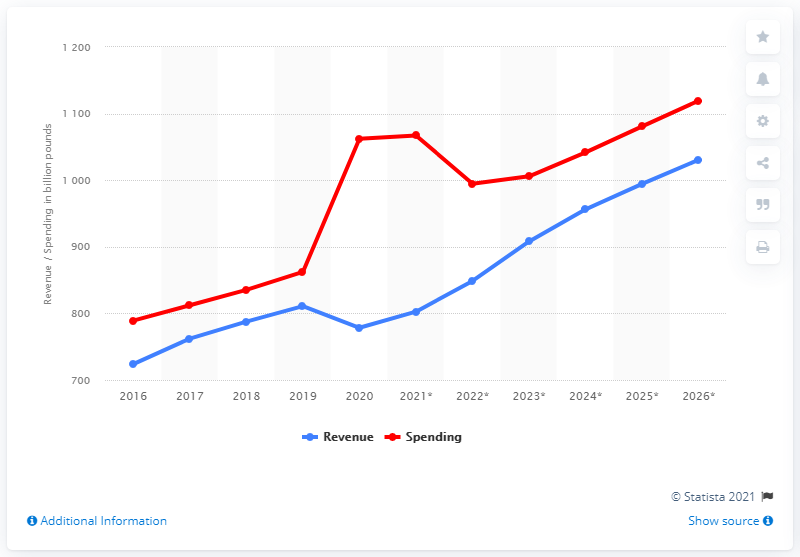List a handful of essential elements in this visual. The government revenue in the United Kingdom in 2020 was 778.44 billion dollars. 